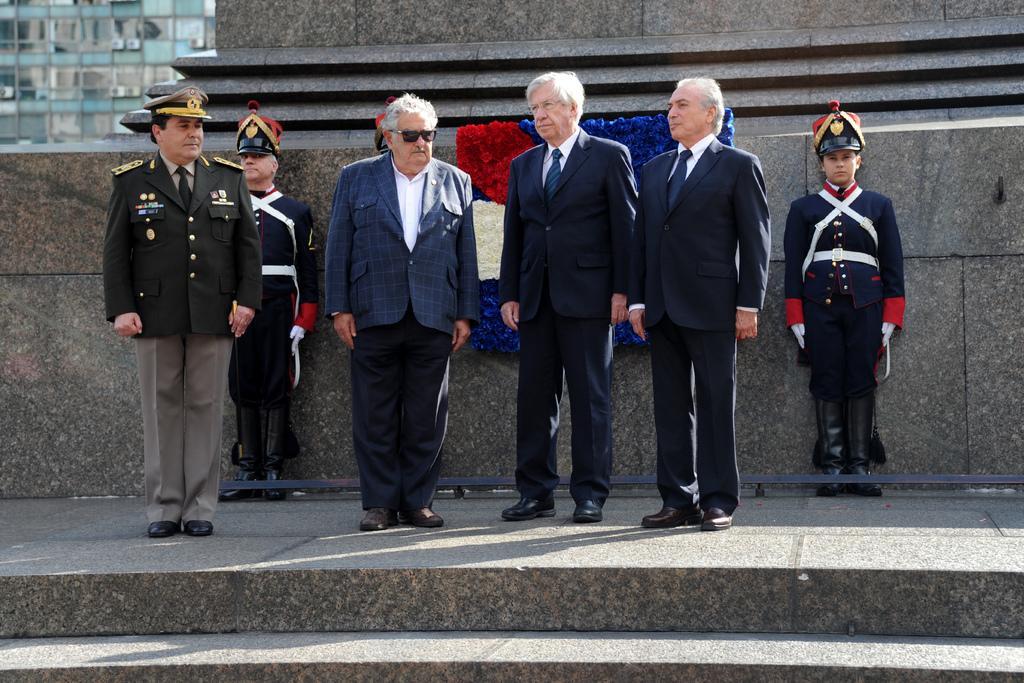How would you summarize this image in a sentence or two? In the center picture there are men standing. In the foreground there is staircase. In the background there is a construction. At the top left there is a building. 